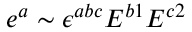Convert formula to latex. <formula><loc_0><loc_0><loc_500><loc_500>e ^ { a } \sim \epsilon ^ { a b c } E ^ { b 1 } E ^ { c 2 }</formula> 